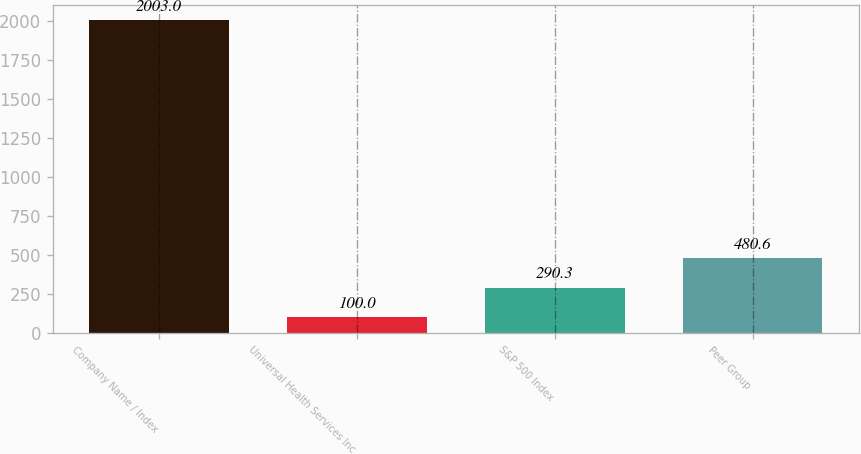<chart> <loc_0><loc_0><loc_500><loc_500><bar_chart><fcel>Company Name / Index<fcel>Universal Health Services Inc<fcel>S&P 500 Index<fcel>Peer Group<nl><fcel>2003<fcel>100<fcel>290.3<fcel>480.6<nl></chart> 